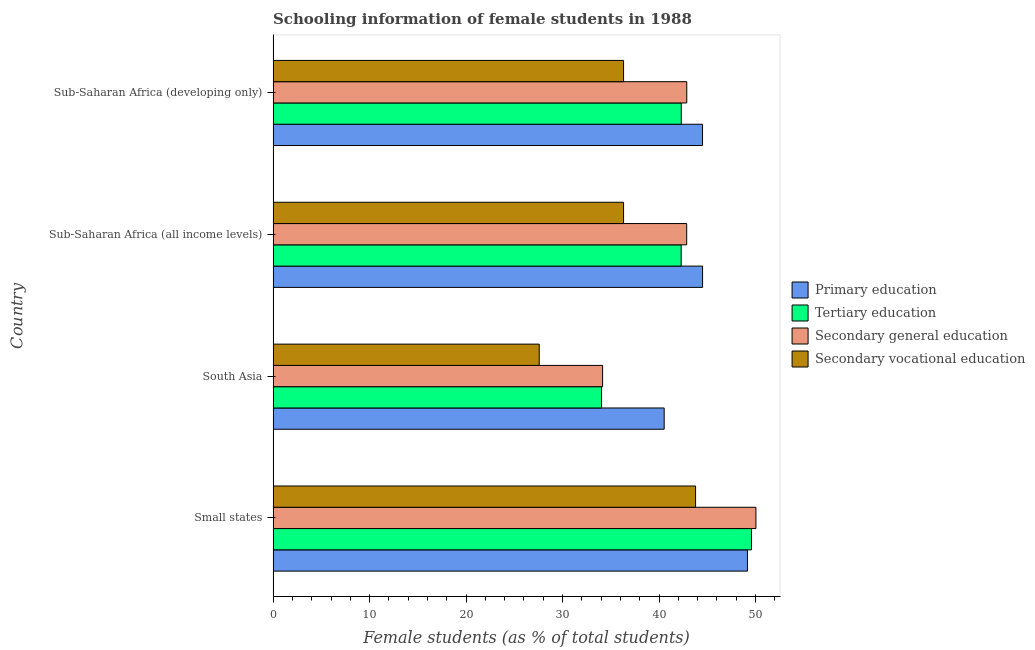How many different coloured bars are there?
Your answer should be compact. 4. Are the number of bars per tick equal to the number of legend labels?
Offer a terse response. Yes. How many bars are there on the 1st tick from the top?
Provide a succinct answer. 4. What is the label of the 2nd group of bars from the top?
Provide a short and direct response. Sub-Saharan Africa (all income levels). What is the percentage of female students in secondary vocational education in South Asia?
Offer a terse response. 27.58. Across all countries, what is the maximum percentage of female students in secondary education?
Provide a short and direct response. 50.04. Across all countries, what is the minimum percentage of female students in secondary education?
Your response must be concise. 34.15. In which country was the percentage of female students in primary education maximum?
Offer a terse response. Small states. In which country was the percentage of female students in secondary education minimum?
Provide a short and direct response. South Asia. What is the total percentage of female students in secondary education in the graph?
Offer a terse response. 169.93. What is the difference between the percentage of female students in tertiary education in Small states and that in South Asia?
Provide a succinct answer. 15.54. What is the difference between the percentage of female students in secondary vocational education in Small states and the percentage of female students in tertiary education in Sub-Saharan Africa (developing only)?
Ensure brevity in your answer.  1.48. What is the average percentage of female students in primary education per country?
Your answer should be compact. 44.68. What is the difference between the percentage of female students in primary education and percentage of female students in tertiary education in Small states?
Make the answer very short. -0.42. In how many countries, is the percentage of female students in secondary vocational education greater than 26 %?
Provide a short and direct response. 4. Is the percentage of female students in primary education in Small states less than that in Sub-Saharan Africa (developing only)?
Make the answer very short. No. What is the difference between the highest and the second highest percentage of female students in secondary vocational education?
Provide a short and direct response. 7.46. What is the difference between the highest and the lowest percentage of female students in secondary education?
Give a very brief answer. 15.89. What does the 2nd bar from the top in Small states represents?
Ensure brevity in your answer.  Secondary general education. What does the 4th bar from the bottom in Small states represents?
Give a very brief answer. Secondary vocational education. Is it the case that in every country, the sum of the percentage of female students in primary education and percentage of female students in tertiary education is greater than the percentage of female students in secondary education?
Offer a very short reply. Yes. How many bars are there?
Provide a short and direct response. 16. How many countries are there in the graph?
Provide a succinct answer. 4. Does the graph contain any zero values?
Provide a succinct answer. No. What is the title of the graph?
Your response must be concise. Schooling information of female students in 1988. Does "WHO" appear as one of the legend labels in the graph?
Provide a succinct answer. No. What is the label or title of the X-axis?
Provide a short and direct response. Female students (as % of total students). What is the label or title of the Y-axis?
Make the answer very short. Country. What is the Female students (as % of total students) of Primary education in Small states?
Your answer should be very brief. 49.16. What is the Female students (as % of total students) of Tertiary education in Small states?
Provide a succinct answer. 49.58. What is the Female students (as % of total students) in Secondary general education in Small states?
Your response must be concise. 50.04. What is the Female students (as % of total students) of Secondary vocational education in Small states?
Your answer should be very brief. 43.79. What is the Female students (as % of total students) in Primary education in South Asia?
Your answer should be very brief. 40.53. What is the Female students (as % of total students) of Tertiary education in South Asia?
Provide a succinct answer. 34.04. What is the Female students (as % of total students) of Secondary general education in South Asia?
Provide a succinct answer. 34.15. What is the Female students (as % of total students) of Secondary vocational education in South Asia?
Offer a terse response. 27.58. What is the Female students (as % of total students) of Primary education in Sub-Saharan Africa (all income levels)?
Your answer should be compact. 44.51. What is the Female students (as % of total students) of Tertiary education in Sub-Saharan Africa (all income levels)?
Give a very brief answer. 42.29. What is the Female students (as % of total students) of Secondary general education in Sub-Saharan Africa (all income levels)?
Your answer should be compact. 42.86. What is the Female students (as % of total students) of Secondary vocational education in Sub-Saharan Africa (all income levels)?
Your answer should be compact. 36.32. What is the Female students (as % of total students) of Primary education in Sub-Saharan Africa (developing only)?
Your answer should be compact. 44.51. What is the Female students (as % of total students) in Tertiary education in Sub-Saharan Africa (developing only)?
Offer a terse response. 42.3. What is the Female students (as % of total students) in Secondary general education in Sub-Saharan Africa (developing only)?
Provide a short and direct response. 42.87. What is the Female students (as % of total students) of Secondary vocational education in Sub-Saharan Africa (developing only)?
Your answer should be compact. 36.32. Across all countries, what is the maximum Female students (as % of total students) of Primary education?
Your answer should be compact. 49.16. Across all countries, what is the maximum Female students (as % of total students) in Tertiary education?
Your answer should be compact. 49.58. Across all countries, what is the maximum Female students (as % of total students) of Secondary general education?
Offer a terse response. 50.04. Across all countries, what is the maximum Female students (as % of total students) of Secondary vocational education?
Provide a succinct answer. 43.79. Across all countries, what is the minimum Female students (as % of total students) in Primary education?
Provide a short and direct response. 40.53. Across all countries, what is the minimum Female students (as % of total students) in Tertiary education?
Provide a succinct answer. 34.04. Across all countries, what is the minimum Female students (as % of total students) in Secondary general education?
Make the answer very short. 34.15. Across all countries, what is the minimum Female students (as % of total students) of Secondary vocational education?
Your answer should be very brief. 27.58. What is the total Female students (as % of total students) in Primary education in the graph?
Give a very brief answer. 178.7. What is the total Female students (as % of total students) of Tertiary education in the graph?
Provide a succinct answer. 168.22. What is the total Female students (as % of total students) of Secondary general education in the graph?
Provide a short and direct response. 169.93. What is the total Female students (as % of total students) in Secondary vocational education in the graph?
Offer a very short reply. 144.01. What is the difference between the Female students (as % of total students) of Primary education in Small states and that in South Asia?
Offer a very short reply. 8.63. What is the difference between the Female students (as % of total students) in Tertiary education in Small states and that in South Asia?
Ensure brevity in your answer.  15.54. What is the difference between the Female students (as % of total students) in Secondary general education in Small states and that in South Asia?
Provide a succinct answer. 15.89. What is the difference between the Female students (as % of total students) in Secondary vocational education in Small states and that in South Asia?
Your response must be concise. 16.2. What is the difference between the Female students (as % of total students) in Primary education in Small states and that in Sub-Saharan Africa (all income levels)?
Your answer should be compact. 4.65. What is the difference between the Female students (as % of total students) of Tertiary education in Small states and that in Sub-Saharan Africa (all income levels)?
Offer a very short reply. 7.29. What is the difference between the Female students (as % of total students) of Secondary general education in Small states and that in Sub-Saharan Africa (all income levels)?
Ensure brevity in your answer.  7.18. What is the difference between the Female students (as % of total students) of Secondary vocational education in Small states and that in Sub-Saharan Africa (all income levels)?
Offer a terse response. 7.46. What is the difference between the Female students (as % of total students) of Primary education in Small states and that in Sub-Saharan Africa (developing only)?
Your answer should be compact. 4.65. What is the difference between the Female students (as % of total students) of Tertiary education in Small states and that in Sub-Saharan Africa (developing only)?
Your answer should be compact. 7.28. What is the difference between the Female students (as % of total students) in Secondary general education in Small states and that in Sub-Saharan Africa (developing only)?
Offer a very short reply. 7.17. What is the difference between the Female students (as % of total students) in Secondary vocational education in Small states and that in Sub-Saharan Africa (developing only)?
Offer a very short reply. 7.46. What is the difference between the Female students (as % of total students) of Primary education in South Asia and that in Sub-Saharan Africa (all income levels)?
Offer a terse response. -3.98. What is the difference between the Female students (as % of total students) of Tertiary education in South Asia and that in Sub-Saharan Africa (all income levels)?
Keep it short and to the point. -8.25. What is the difference between the Female students (as % of total students) of Secondary general education in South Asia and that in Sub-Saharan Africa (all income levels)?
Offer a very short reply. -8.72. What is the difference between the Female students (as % of total students) of Secondary vocational education in South Asia and that in Sub-Saharan Africa (all income levels)?
Make the answer very short. -8.74. What is the difference between the Female students (as % of total students) of Primary education in South Asia and that in Sub-Saharan Africa (developing only)?
Make the answer very short. -3.97. What is the difference between the Female students (as % of total students) of Tertiary education in South Asia and that in Sub-Saharan Africa (developing only)?
Provide a short and direct response. -8.26. What is the difference between the Female students (as % of total students) of Secondary general education in South Asia and that in Sub-Saharan Africa (developing only)?
Offer a very short reply. -8.73. What is the difference between the Female students (as % of total students) in Secondary vocational education in South Asia and that in Sub-Saharan Africa (developing only)?
Your answer should be compact. -8.74. What is the difference between the Female students (as % of total students) of Primary education in Sub-Saharan Africa (all income levels) and that in Sub-Saharan Africa (developing only)?
Your answer should be very brief. 0. What is the difference between the Female students (as % of total students) in Tertiary education in Sub-Saharan Africa (all income levels) and that in Sub-Saharan Africa (developing only)?
Your answer should be very brief. -0.01. What is the difference between the Female students (as % of total students) in Secondary general education in Sub-Saharan Africa (all income levels) and that in Sub-Saharan Africa (developing only)?
Keep it short and to the point. -0.01. What is the difference between the Female students (as % of total students) in Secondary vocational education in Sub-Saharan Africa (all income levels) and that in Sub-Saharan Africa (developing only)?
Ensure brevity in your answer.  0. What is the difference between the Female students (as % of total students) in Primary education in Small states and the Female students (as % of total students) in Tertiary education in South Asia?
Your answer should be very brief. 15.12. What is the difference between the Female students (as % of total students) of Primary education in Small states and the Female students (as % of total students) of Secondary general education in South Asia?
Keep it short and to the point. 15.01. What is the difference between the Female students (as % of total students) of Primary education in Small states and the Female students (as % of total students) of Secondary vocational education in South Asia?
Keep it short and to the point. 21.58. What is the difference between the Female students (as % of total students) of Tertiary education in Small states and the Female students (as % of total students) of Secondary general education in South Asia?
Give a very brief answer. 15.43. What is the difference between the Female students (as % of total students) of Tertiary education in Small states and the Female students (as % of total students) of Secondary vocational education in South Asia?
Offer a very short reply. 22. What is the difference between the Female students (as % of total students) in Secondary general education in Small states and the Female students (as % of total students) in Secondary vocational education in South Asia?
Ensure brevity in your answer.  22.46. What is the difference between the Female students (as % of total students) in Primary education in Small states and the Female students (as % of total students) in Tertiary education in Sub-Saharan Africa (all income levels)?
Provide a short and direct response. 6.87. What is the difference between the Female students (as % of total students) in Primary education in Small states and the Female students (as % of total students) in Secondary general education in Sub-Saharan Africa (all income levels)?
Keep it short and to the point. 6.29. What is the difference between the Female students (as % of total students) in Primary education in Small states and the Female students (as % of total students) in Secondary vocational education in Sub-Saharan Africa (all income levels)?
Offer a very short reply. 12.84. What is the difference between the Female students (as % of total students) in Tertiary education in Small states and the Female students (as % of total students) in Secondary general education in Sub-Saharan Africa (all income levels)?
Ensure brevity in your answer.  6.72. What is the difference between the Female students (as % of total students) of Tertiary education in Small states and the Female students (as % of total students) of Secondary vocational education in Sub-Saharan Africa (all income levels)?
Provide a short and direct response. 13.26. What is the difference between the Female students (as % of total students) in Secondary general education in Small states and the Female students (as % of total students) in Secondary vocational education in Sub-Saharan Africa (all income levels)?
Give a very brief answer. 13.72. What is the difference between the Female students (as % of total students) in Primary education in Small states and the Female students (as % of total students) in Tertiary education in Sub-Saharan Africa (developing only)?
Your answer should be very brief. 6.86. What is the difference between the Female students (as % of total students) in Primary education in Small states and the Female students (as % of total students) in Secondary general education in Sub-Saharan Africa (developing only)?
Make the answer very short. 6.29. What is the difference between the Female students (as % of total students) of Primary education in Small states and the Female students (as % of total students) of Secondary vocational education in Sub-Saharan Africa (developing only)?
Give a very brief answer. 12.84. What is the difference between the Female students (as % of total students) of Tertiary education in Small states and the Female students (as % of total students) of Secondary general education in Sub-Saharan Africa (developing only)?
Your answer should be very brief. 6.71. What is the difference between the Female students (as % of total students) in Tertiary education in Small states and the Female students (as % of total students) in Secondary vocational education in Sub-Saharan Africa (developing only)?
Your response must be concise. 13.26. What is the difference between the Female students (as % of total students) of Secondary general education in Small states and the Female students (as % of total students) of Secondary vocational education in Sub-Saharan Africa (developing only)?
Offer a very short reply. 13.72. What is the difference between the Female students (as % of total students) of Primary education in South Asia and the Female students (as % of total students) of Tertiary education in Sub-Saharan Africa (all income levels)?
Your response must be concise. -1.76. What is the difference between the Female students (as % of total students) of Primary education in South Asia and the Female students (as % of total students) of Secondary general education in Sub-Saharan Africa (all income levels)?
Offer a terse response. -2.33. What is the difference between the Female students (as % of total students) in Primary education in South Asia and the Female students (as % of total students) in Secondary vocational education in Sub-Saharan Africa (all income levels)?
Give a very brief answer. 4.21. What is the difference between the Female students (as % of total students) of Tertiary education in South Asia and the Female students (as % of total students) of Secondary general education in Sub-Saharan Africa (all income levels)?
Keep it short and to the point. -8.82. What is the difference between the Female students (as % of total students) of Tertiary education in South Asia and the Female students (as % of total students) of Secondary vocational education in Sub-Saharan Africa (all income levels)?
Your response must be concise. -2.28. What is the difference between the Female students (as % of total students) of Secondary general education in South Asia and the Female students (as % of total students) of Secondary vocational education in Sub-Saharan Africa (all income levels)?
Your answer should be compact. -2.17. What is the difference between the Female students (as % of total students) in Primary education in South Asia and the Female students (as % of total students) in Tertiary education in Sub-Saharan Africa (developing only)?
Your answer should be very brief. -1.77. What is the difference between the Female students (as % of total students) in Primary education in South Asia and the Female students (as % of total students) in Secondary general education in Sub-Saharan Africa (developing only)?
Offer a very short reply. -2.34. What is the difference between the Female students (as % of total students) in Primary education in South Asia and the Female students (as % of total students) in Secondary vocational education in Sub-Saharan Africa (developing only)?
Make the answer very short. 4.21. What is the difference between the Female students (as % of total students) of Tertiary education in South Asia and the Female students (as % of total students) of Secondary general education in Sub-Saharan Africa (developing only)?
Make the answer very short. -8.83. What is the difference between the Female students (as % of total students) in Tertiary education in South Asia and the Female students (as % of total students) in Secondary vocational education in Sub-Saharan Africa (developing only)?
Ensure brevity in your answer.  -2.28. What is the difference between the Female students (as % of total students) of Secondary general education in South Asia and the Female students (as % of total students) of Secondary vocational education in Sub-Saharan Africa (developing only)?
Offer a terse response. -2.17. What is the difference between the Female students (as % of total students) of Primary education in Sub-Saharan Africa (all income levels) and the Female students (as % of total students) of Tertiary education in Sub-Saharan Africa (developing only)?
Your answer should be very brief. 2.21. What is the difference between the Female students (as % of total students) in Primary education in Sub-Saharan Africa (all income levels) and the Female students (as % of total students) in Secondary general education in Sub-Saharan Africa (developing only)?
Give a very brief answer. 1.64. What is the difference between the Female students (as % of total students) of Primary education in Sub-Saharan Africa (all income levels) and the Female students (as % of total students) of Secondary vocational education in Sub-Saharan Africa (developing only)?
Offer a very short reply. 8.19. What is the difference between the Female students (as % of total students) of Tertiary education in Sub-Saharan Africa (all income levels) and the Female students (as % of total students) of Secondary general education in Sub-Saharan Africa (developing only)?
Give a very brief answer. -0.58. What is the difference between the Female students (as % of total students) of Tertiary education in Sub-Saharan Africa (all income levels) and the Female students (as % of total students) of Secondary vocational education in Sub-Saharan Africa (developing only)?
Your answer should be compact. 5.97. What is the difference between the Female students (as % of total students) of Secondary general education in Sub-Saharan Africa (all income levels) and the Female students (as % of total students) of Secondary vocational education in Sub-Saharan Africa (developing only)?
Ensure brevity in your answer.  6.54. What is the average Female students (as % of total students) of Primary education per country?
Give a very brief answer. 44.68. What is the average Female students (as % of total students) of Tertiary education per country?
Make the answer very short. 42.05. What is the average Female students (as % of total students) in Secondary general education per country?
Your response must be concise. 42.48. What is the average Female students (as % of total students) in Secondary vocational education per country?
Ensure brevity in your answer.  36. What is the difference between the Female students (as % of total students) in Primary education and Female students (as % of total students) in Tertiary education in Small states?
Give a very brief answer. -0.42. What is the difference between the Female students (as % of total students) in Primary education and Female students (as % of total students) in Secondary general education in Small states?
Ensure brevity in your answer.  -0.88. What is the difference between the Female students (as % of total students) of Primary education and Female students (as % of total students) of Secondary vocational education in Small states?
Provide a short and direct response. 5.37. What is the difference between the Female students (as % of total students) in Tertiary education and Female students (as % of total students) in Secondary general education in Small states?
Offer a very short reply. -0.46. What is the difference between the Female students (as % of total students) of Tertiary education and Female students (as % of total students) of Secondary vocational education in Small states?
Your response must be concise. 5.8. What is the difference between the Female students (as % of total students) in Secondary general education and Female students (as % of total students) in Secondary vocational education in Small states?
Your answer should be very brief. 6.26. What is the difference between the Female students (as % of total students) of Primary education and Female students (as % of total students) of Tertiary education in South Asia?
Your answer should be compact. 6.49. What is the difference between the Female students (as % of total students) of Primary education and Female students (as % of total students) of Secondary general education in South Asia?
Your answer should be very brief. 6.38. What is the difference between the Female students (as % of total students) of Primary education and Female students (as % of total students) of Secondary vocational education in South Asia?
Your response must be concise. 12.95. What is the difference between the Female students (as % of total students) of Tertiary education and Female students (as % of total students) of Secondary general education in South Asia?
Your answer should be compact. -0.11. What is the difference between the Female students (as % of total students) in Tertiary education and Female students (as % of total students) in Secondary vocational education in South Asia?
Offer a very short reply. 6.46. What is the difference between the Female students (as % of total students) in Secondary general education and Female students (as % of total students) in Secondary vocational education in South Asia?
Give a very brief answer. 6.57. What is the difference between the Female students (as % of total students) in Primary education and Female students (as % of total students) in Tertiary education in Sub-Saharan Africa (all income levels)?
Make the answer very short. 2.22. What is the difference between the Female students (as % of total students) of Primary education and Female students (as % of total students) of Secondary general education in Sub-Saharan Africa (all income levels)?
Provide a succinct answer. 1.65. What is the difference between the Female students (as % of total students) in Primary education and Female students (as % of total students) in Secondary vocational education in Sub-Saharan Africa (all income levels)?
Your response must be concise. 8.19. What is the difference between the Female students (as % of total students) in Tertiary education and Female students (as % of total students) in Secondary general education in Sub-Saharan Africa (all income levels)?
Make the answer very short. -0.57. What is the difference between the Female students (as % of total students) in Tertiary education and Female students (as % of total students) in Secondary vocational education in Sub-Saharan Africa (all income levels)?
Your answer should be very brief. 5.97. What is the difference between the Female students (as % of total students) in Secondary general education and Female students (as % of total students) in Secondary vocational education in Sub-Saharan Africa (all income levels)?
Your answer should be very brief. 6.54. What is the difference between the Female students (as % of total students) of Primary education and Female students (as % of total students) of Tertiary education in Sub-Saharan Africa (developing only)?
Provide a short and direct response. 2.2. What is the difference between the Female students (as % of total students) in Primary education and Female students (as % of total students) in Secondary general education in Sub-Saharan Africa (developing only)?
Your answer should be very brief. 1.63. What is the difference between the Female students (as % of total students) of Primary education and Female students (as % of total students) of Secondary vocational education in Sub-Saharan Africa (developing only)?
Provide a succinct answer. 8.18. What is the difference between the Female students (as % of total students) in Tertiary education and Female students (as % of total students) in Secondary general education in Sub-Saharan Africa (developing only)?
Your response must be concise. -0.57. What is the difference between the Female students (as % of total students) in Tertiary education and Female students (as % of total students) in Secondary vocational education in Sub-Saharan Africa (developing only)?
Your response must be concise. 5.98. What is the difference between the Female students (as % of total students) in Secondary general education and Female students (as % of total students) in Secondary vocational education in Sub-Saharan Africa (developing only)?
Offer a terse response. 6.55. What is the ratio of the Female students (as % of total students) of Primary education in Small states to that in South Asia?
Your response must be concise. 1.21. What is the ratio of the Female students (as % of total students) in Tertiary education in Small states to that in South Asia?
Make the answer very short. 1.46. What is the ratio of the Female students (as % of total students) in Secondary general education in Small states to that in South Asia?
Keep it short and to the point. 1.47. What is the ratio of the Female students (as % of total students) in Secondary vocational education in Small states to that in South Asia?
Your response must be concise. 1.59. What is the ratio of the Female students (as % of total students) of Primary education in Small states to that in Sub-Saharan Africa (all income levels)?
Your answer should be compact. 1.1. What is the ratio of the Female students (as % of total students) in Tertiary education in Small states to that in Sub-Saharan Africa (all income levels)?
Provide a short and direct response. 1.17. What is the ratio of the Female students (as % of total students) of Secondary general education in Small states to that in Sub-Saharan Africa (all income levels)?
Make the answer very short. 1.17. What is the ratio of the Female students (as % of total students) in Secondary vocational education in Small states to that in Sub-Saharan Africa (all income levels)?
Provide a succinct answer. 1.21. What is the ratio of the Female students (as % of total students) in Primary education in Small states to that in Sub-Saharan Africa (developing only)?
Provide a succinct answer. 1.1. What is the ratio of the Female students (as % of total students) in Tertiary education in Small states to that in Sub-Saharan Africa (developing only)?
Offer a very short reply. 1.17. What is the ratio of the Female students (as % of total students) in Secondary general education in Small states to that in Sub-Saharan Africa (developing only)?
Offer a terse response. 1.17. What is the ratio of the Female students (as % of total students) in Secondary vocational education in Small states to that in Sub-Saharan Africa (developing only)?
Provide a succinct answer. 1.21. What is the ratio of the Female students (as % of total students) in Primary education in South Asia to that in Sub-Saharan Africa (all income levels)?
Your answer should be compact. 0.91. What is the ratio of the Female students (as % of total students) of Tertiary education in South Asia to that in Sub-Saharan Africa (all income levels)?
Your answer should be compact. 0.8. What is the ratio of the Female students (as % of total students) in Secondary general education in South Asia to that in Sub-Saharan Africa (all income levels)?
Ensure brevity in your answer.  0.8. What is the ratio of the Female students (as % of total students) of Secondary vocational education in South Asia to that in Sub-Saharan Africa (all income levels)?
Keep it short and to the point. 0.76. What is the ratio of the Female students (as % of total students) of Primary education in South Asia to that in Sub-Saharan Africa (developing only)?
Keep it short and to the point. 0.91. What is the ratio of the Female students (as % of total students) of Tertiary education in South Asia to that in Sub-Saharan Africa (developing only)?
Provide a short and direct response. 0.8. What is the ratio of the Female students (as % of total students) of Secondary general education in South Asia to that in Sub-Saharan Africa (developing only)?
Your answer should be very brief. 0.8. What is the ratio of the Female students (as % of total students) in Secondary vocational education in South Asia to that in Sub-Saharan Africa (developing only)?
Provide a short and direct response. 0.76. What is the ratio of the Female students (as % of total students) of Primary education in Sub-Saharan Africa (all income levels) to that in Sub-Saharan Africa (developing only)?
Keep it short and to the point. 1. What is the ratio of the Female students (as % of total students) of Tertiary education in Sub-Saharan Africa (all income levels) to that in Sub-Saharan Africa (developing only)?
Keep it short and to the point. 1. What is the ratio of the Female students (as % of total students) in Secondary general education in Sub-Saharan Africa (all income levels) to that in Sub-Saharan Africa (developing only)?
Offer a terse response. 1. What is the ratio of the Female students (as % of total students) of Secondary vocational education in Sub-Saharan Africa (all income levels) to that in Sub-Saharan Africa (developing only)?
Your response must be concise. 1. What is the difference between the highest and the second highest Female students (as % of total students) in Primary education?
Offer a very short reply. 4.65. What is the difference between the highest and the second highest Female students (as % of total students) of Tertiary education?
Offer a very short reply. 7.28. What is the difference between the highest and the second highest Female students (as % of total students) in Secondary general education?
Give a very brief answer. 7.17. What is the difference between the highest and the second highest Female students (as % of total students) of Secondary vocational education?
Provide a short and direct response. 7.46. What is the difference between the highest and the lowest Female students (as % of total students) of Primary education?
Your response must be concise. 8.63. What is the difference between the highest and the lowest Female students (as % of total students) of Tertiary education?
Give a very brief answer. 15.54. What is the difference between the highest and the lowest Female students (as % of total students) of Secondary general education?
Offer a very short reply. 15.89. What is the difference between the highest and the lowest Female students (as % of total students) in Secondary vocational education?
Your answer should be very brief. 16.2. 